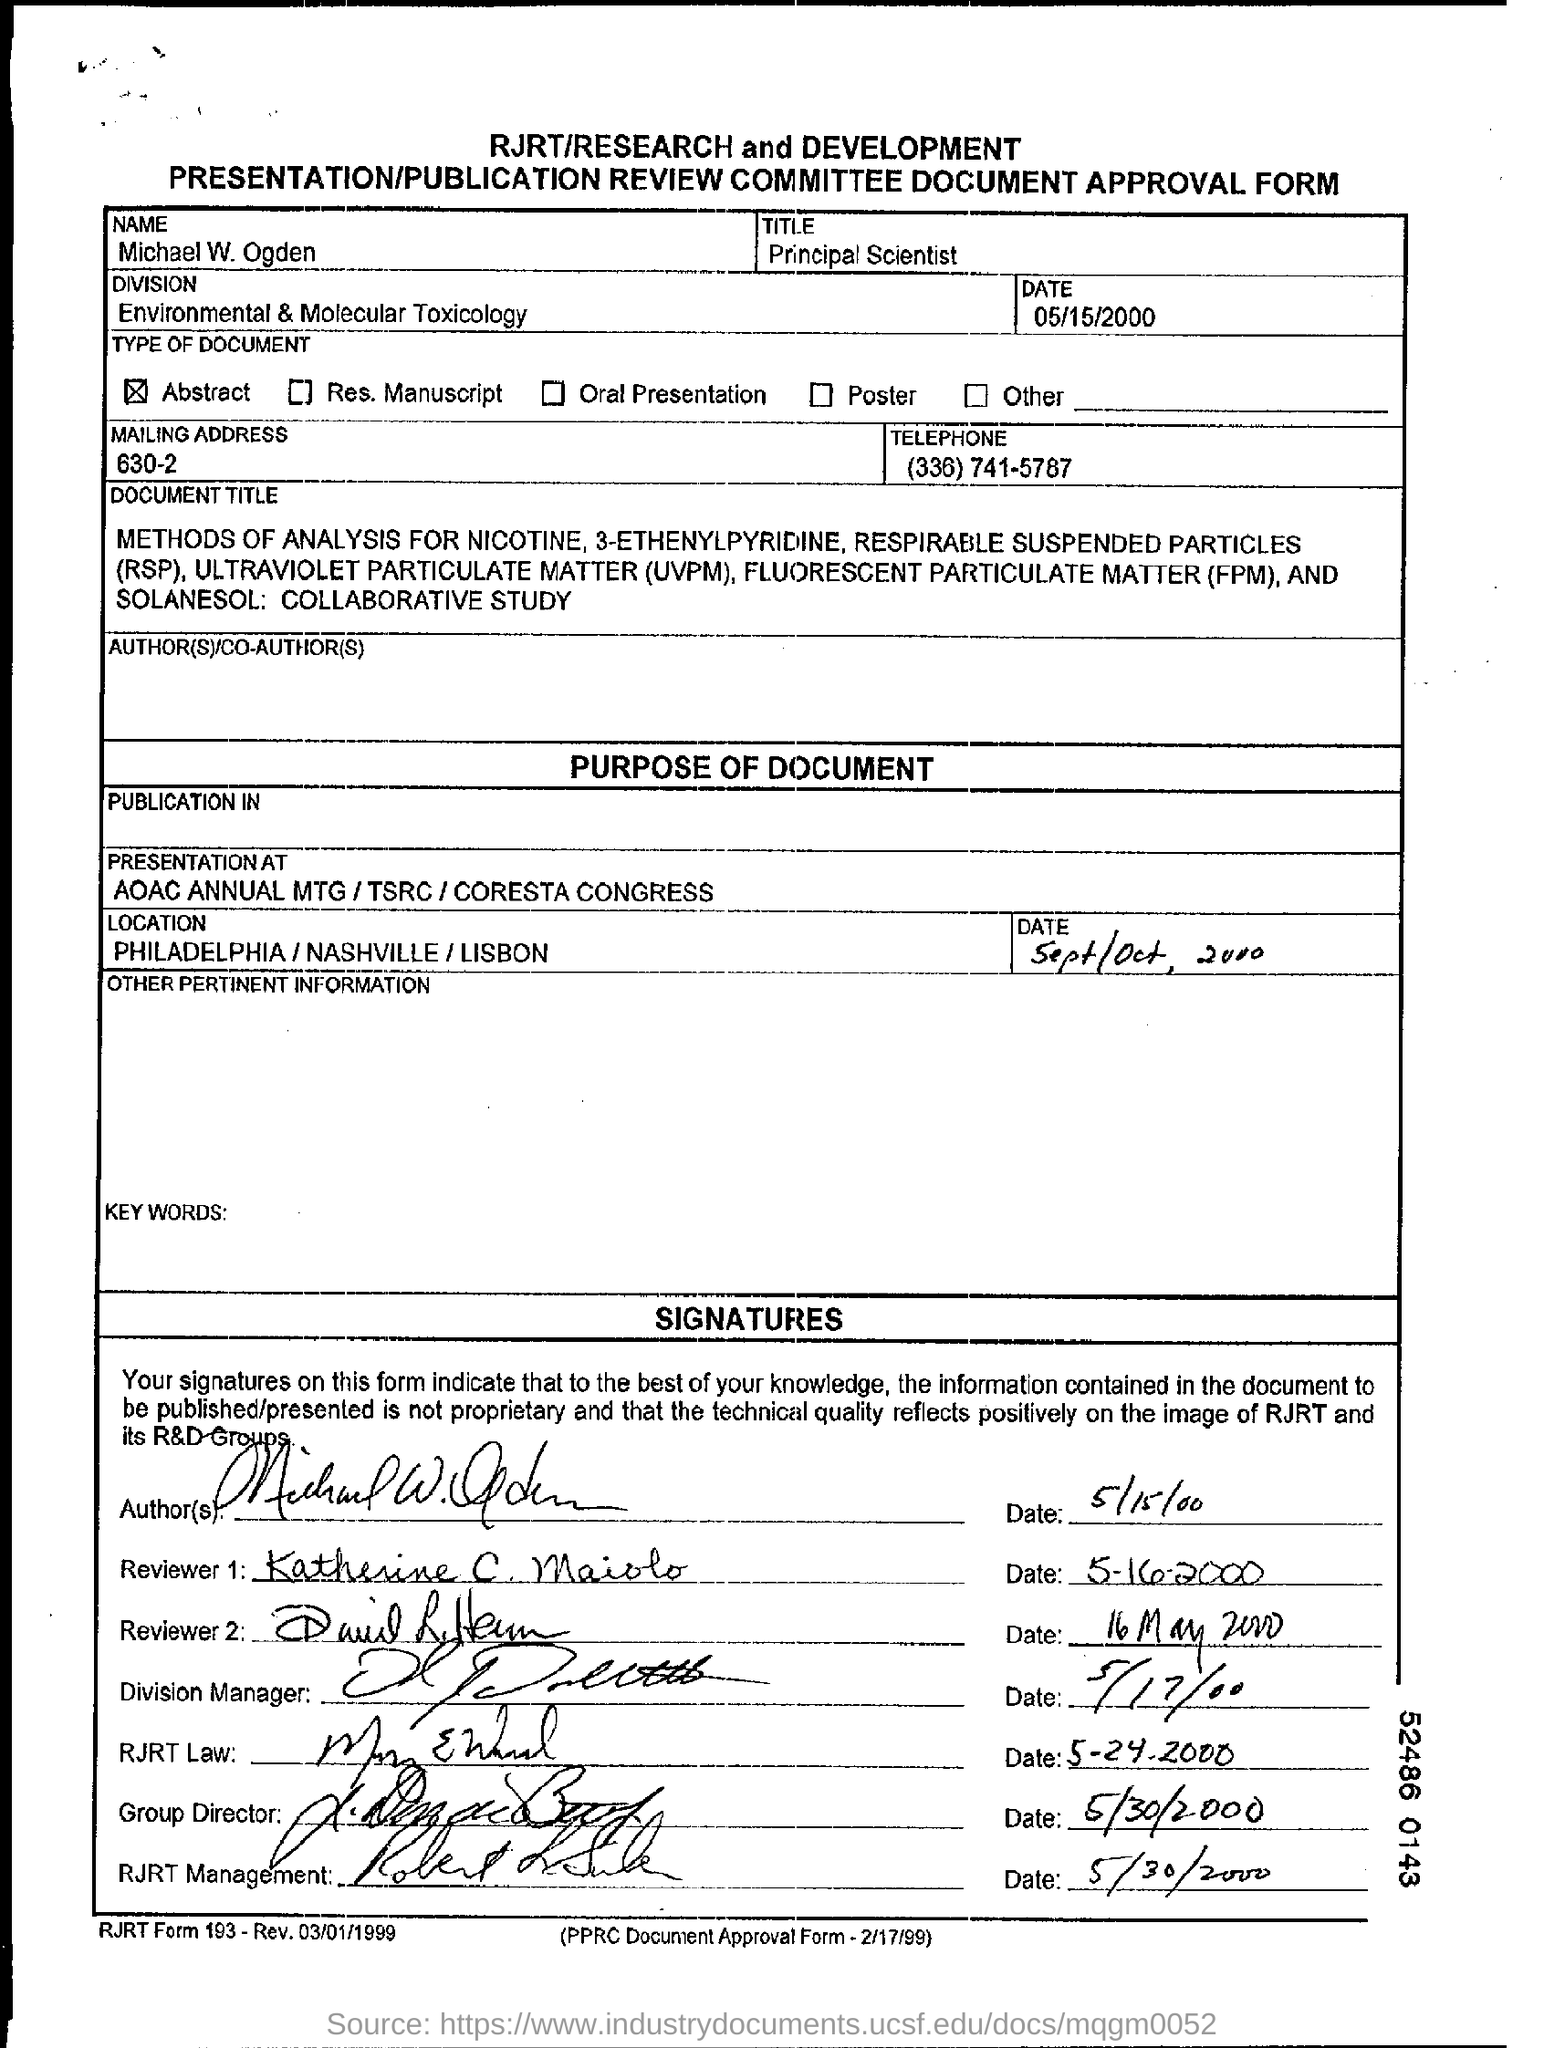Point out several critical features in this image. The date mentioned at the top of this document is May 15, 2000. The title in the title field is 'Principal Scientist.' The Name Field contains the name "Michael W. Ogden. The Division Field contains the written text "Environmental & Molecular Toxicology. The telephone number is 336-741-5787. 